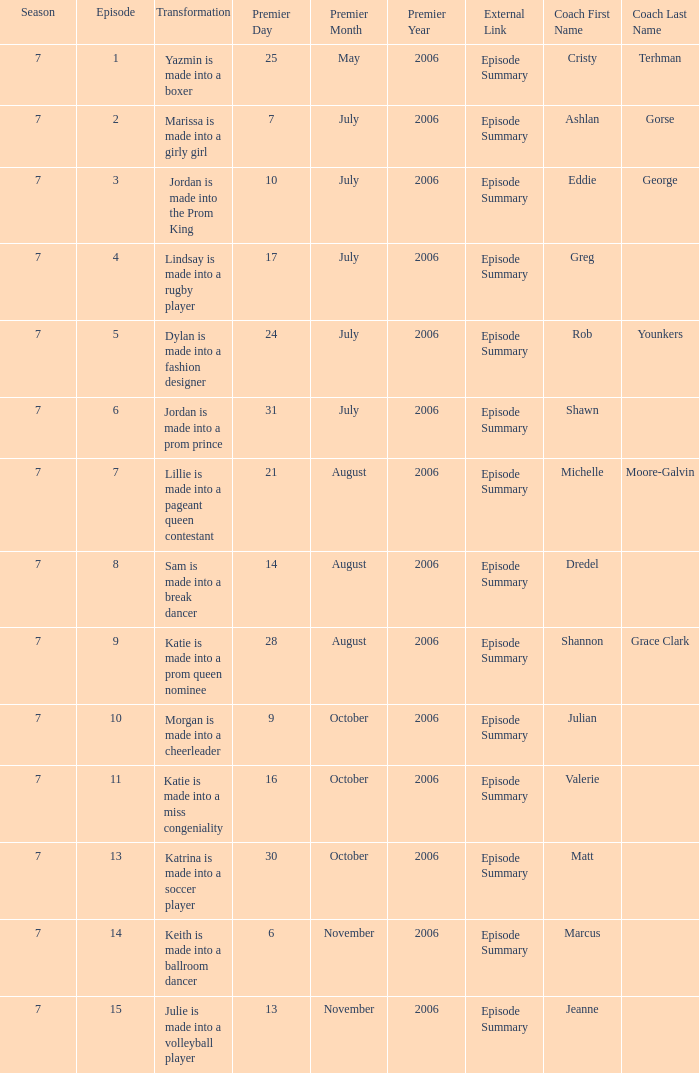What is the newest season? 7.0. 